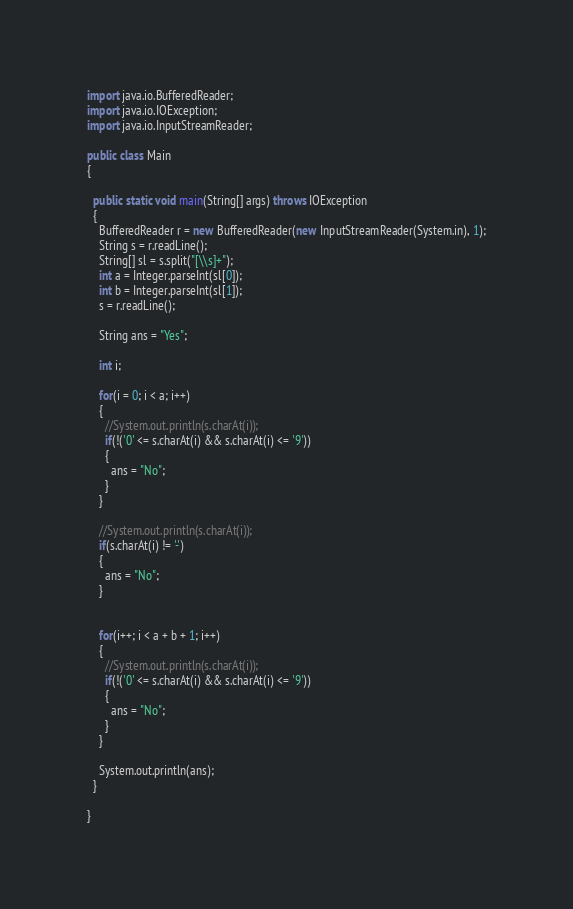Convert code to text. <code><loc_0><loc_0><loc_500><loc_500><_Java_>import java.io.BufferedReader;
import java.io.IOException;
import java.io.InputStreamReader;

public class Main
{

  public static void main(String[] args) throws IOException
  {
    BufferedReader r = new BufferedReader(new InputStreamReader(System.in), 1);
    String s = r.readLine();
    String[] sl = s.split("[\\s]+");
    int a = Integer.parseInt(sl[0]);
    int b = Integer.parseInt(sl[1]);
    s = r.readLine();

    String ans = "Yes";

    int i;

    for(i = 0; i < a; i++)
    {
      //System.out.println(s.charAt(i));
      if(!('0' <= s.charAt(i) && s.charAt(i) <= '9'))
      {
        ans = "No";
      }
    }

    //System.out.println(s.charAt(i));
    if(s.charAt(i) != '-')
    {
      ans = "No";
    }


    for(i++; i < a + b + 1; i++)
    {
      //System.out.println(s.charAt(i));
      if(!('0' <= s.charAt(i) && s.charAt(i) <= '9'))
      {
        ans = "No";
      }
    }

    System.out.println(ans);
  }

}
</code> 